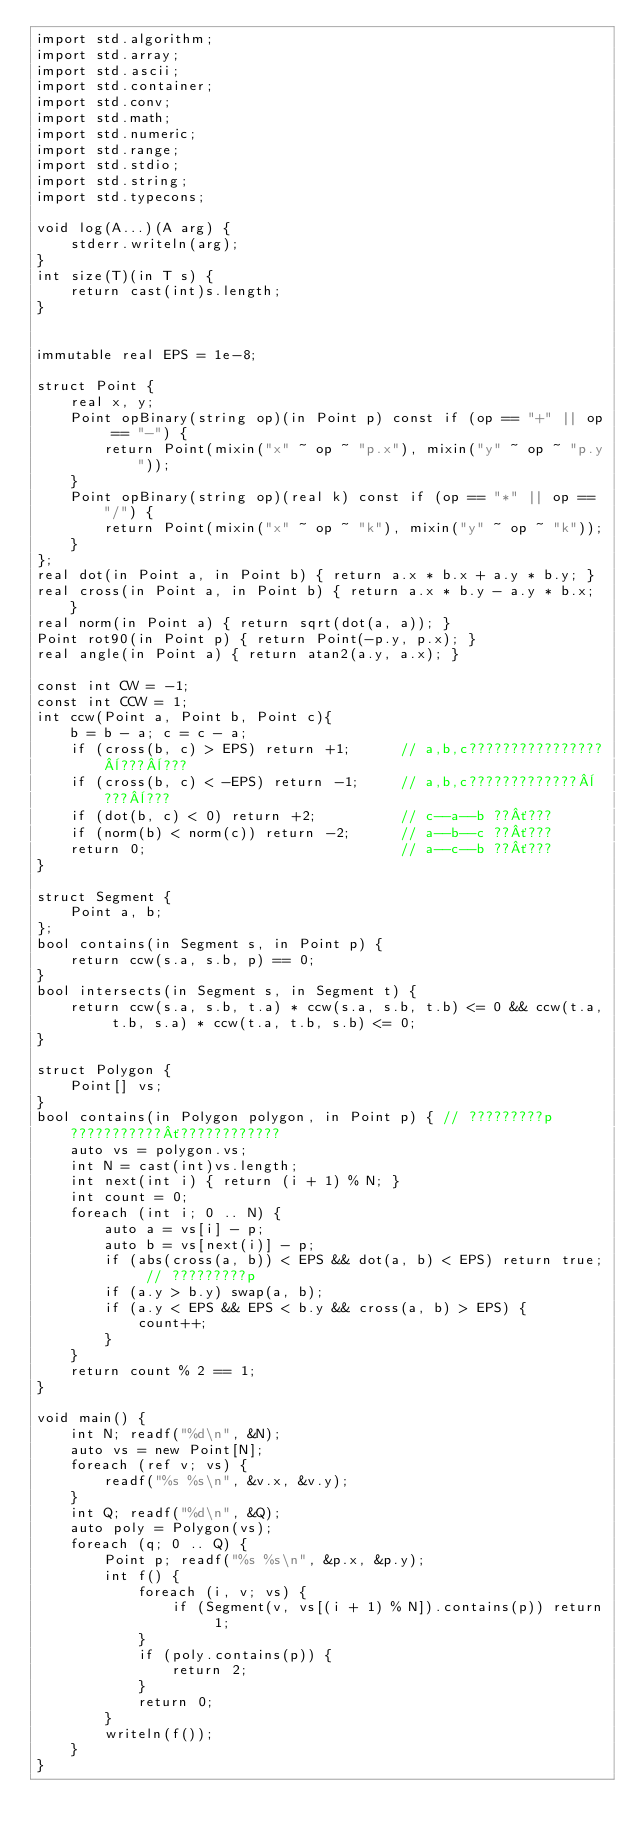<code> <loc_0><loc_0><loc_500><loc_500><_D_>import std.algorithm;
import std.array;
import std.ascii;
import std.container;
import std.conv;
import std.math;
import std.numeric;
import std.range;
import std.stdio;
import std.string;
import std.typecons;

void log(A...)(A arg) {
    stderr.writeln(arg);
}
int size(T)(in T s) {
    return cast(int)s.length;
}


immutable real EPS = 1e-8;

struct Point {
    real x, y;
    Point opBinary(string op)(in Point p) const if (op == "+" || op == "-") {
        return Point(mixin("x" ~ op ~ "p.x"), mixin("y" ~ op ~ "p.y"));
    }
    Point opBinary(string op)(real k) const if (op == "*" || op == "/") {
        return Point(mixin("x" ~ op ~ "k"), mixin("y" ~ op ~ "k"));
    }
};
real dot(in Point a, in Point b) { return a.x * b.x + a.y * b.y; }
real cross(in Point a, in Point b) { return a.x * b.y - a.y * b.x; }
real norm(in Point a) { return sqrt(dot(a, a)); }
Point rot90(in Point p) { return Point(-p.y, p.x); }
real angle(in Point a) { return atan2(a.y, a.x); }

const int CW = -1;
const int CCW = 1;
int ccw(Point a, Point b, Point c){
    b = b - a; c = c - a;                                          
    if (cross(b, c) > EPS) return +1;      // a,b,c????????????????¨???¨???
    if (cross(b, c) < -EPS) return -1;     // a,b,c?????????????¨???¨???                       
    if (dot(b, c) < 0) return +2;          // c--a--b ??´???                       
    if (norm(b) < norm(c)) return -2;      // a--b--c ??´???                       
    return 0;                              // a--c--b ??´???
}

struct Segment {
    Point a, b;
};
bool contains(in Segment s, in Point p) {
    return ccw(s.a, s.b, p) == 0;
}
bool intersects(in Segment s, in Segment t) {
    return ccw(s.a, s.b, t.a) * ccw(s.a, s.b, t.b) <= 0 && ccw(t.a, t.b, s.a) * ccw(t.a, t.b, s.b) <= 0;
}

struct Polygon {
    Point[] vs;
}
bool contains(in Polygon polygon, in Point p) { // ?????????p???????????´????????????
    auto vs = polygon.vs;
    int N = cast(int)vs.length;
    int next(int i) { return (i + 1) % N; }
    int count = 0;
    foreach (int i; 0 .. N) {
        auto a = vs[i] - p;
        auto b = vs[next(i)] - p;
        if (abs(cross(a, b)) < EPS && dot(a, b) < EPS) return true; // ?????????p
        if (a.y > b.y) swap(a, b);
        if (a.y < EPS && EPS < b.y && cross(a, b) > EPS) {
            count++;
        }
    }
    return count % 2 == 1;
}

void main() {
    int N; readf("%d\n", &N);
    auto vs = new Point[N];
    foreach (ref v; vs) {
        readf("%s %s\n", &v.x, &v.y);
    }
    int Q; readf("%d\n", &Q);
    auto poly = Polygon(vs);
    foreach (q; 0 .. Q) {
        Point p; readf("%s %s\n", &p.x, &p.y);
        int f() {
            foreach (i, v; vs) {
                if (Segment(v, vs[(i + 1) % N]).contains(p)) return 1;
            }
            if (poly.contains(p)) {
                return 2;
            }
            return 0;
        }
        writeln(f());
    }
}</code> 